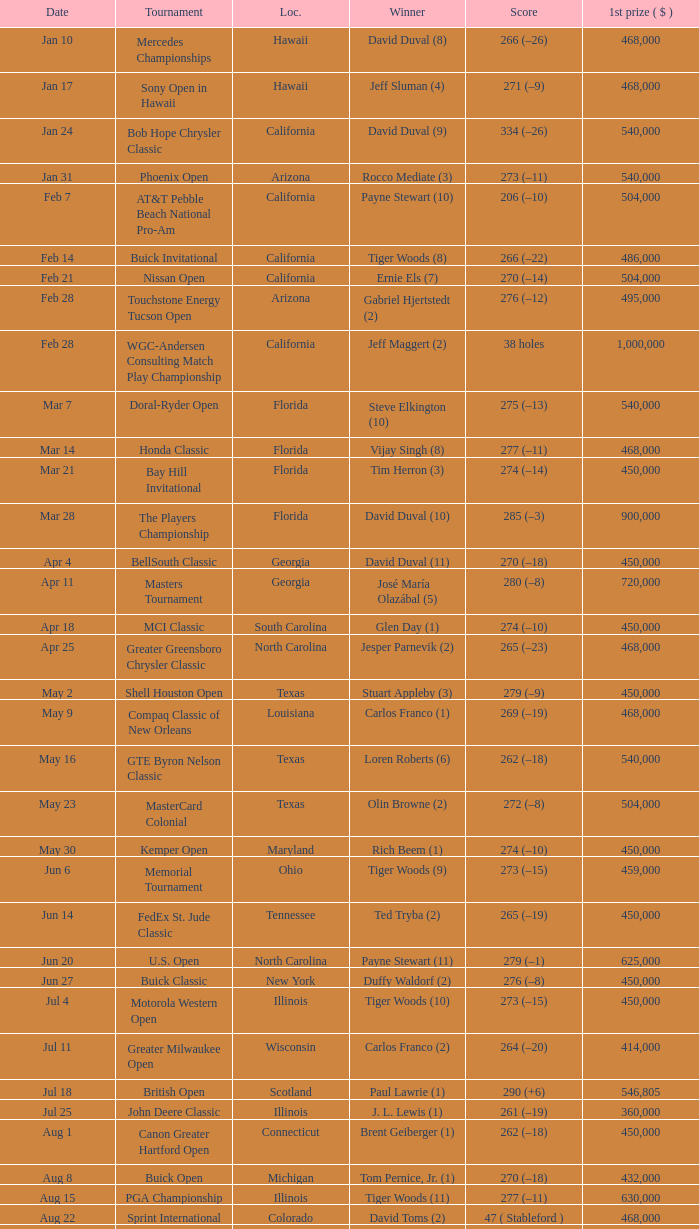What is the date of the Greater Greensboro Chrysler Classic? Apr 25. 